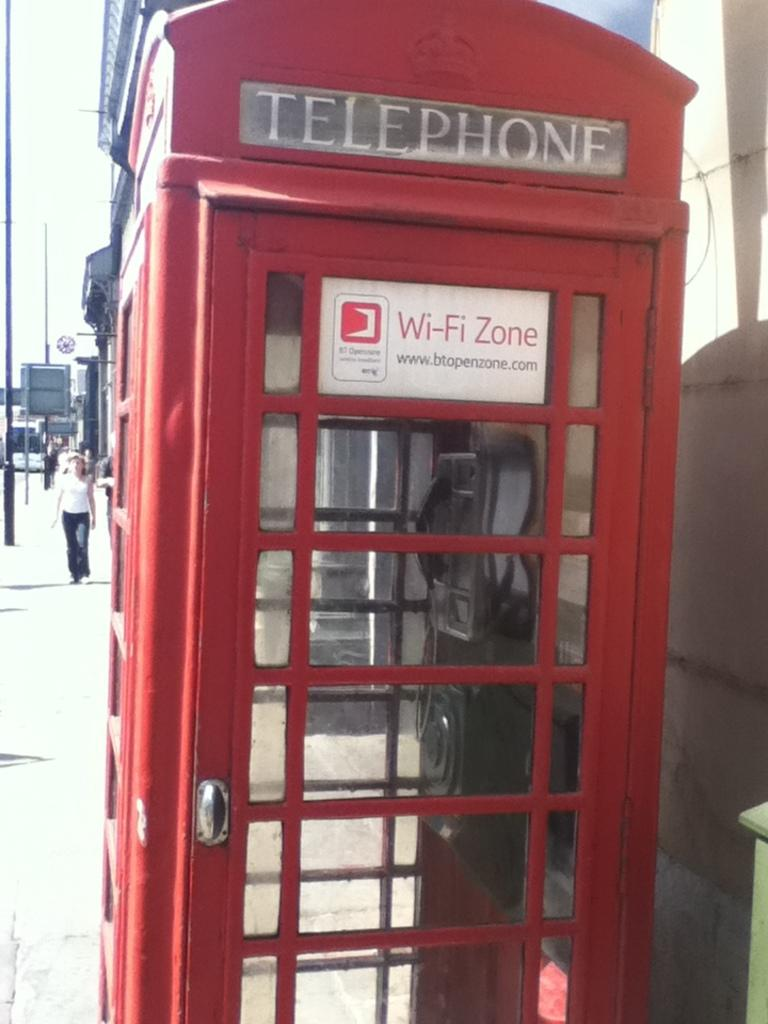<image>
Provide a brief description of the given image. A British red phone box has a sign saying WI-fi zone on it 